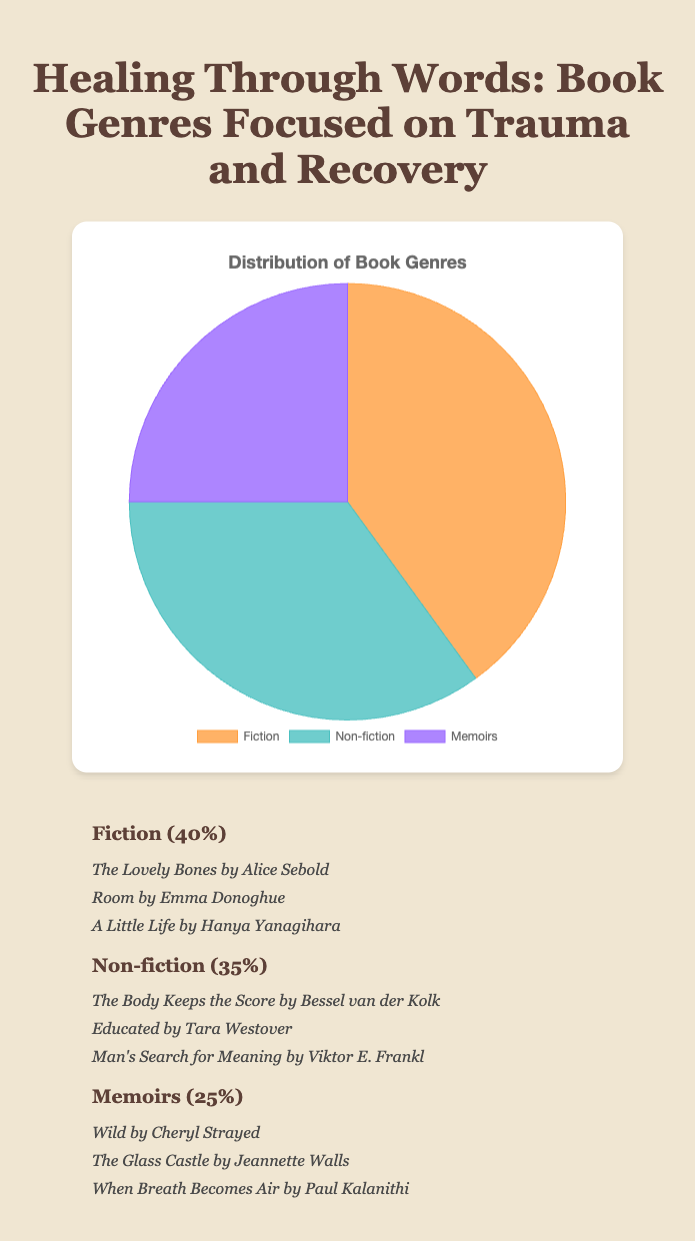What percentage of books focused on trauma and recovery belong to the Fiction genre? Looking at the pie chart, the Fiction portion accounts for 40% of the books focused on trauma and recovery.
Answer: 40% Which genre has the lowest percentage of books focused on trauma and recovery? By analyzing the pie chart, we can see that Memoirs have the smallest section, representing 25% of the books.
Answer: Memoirs How much greater is the percentage of Fiction books compared to Memoirs? Fiction accounts for 40%, while Memoirs account for 25%. The difference in percentage is 40% - 25% = 15%.
Answer: 15% What is the combined percentage of Non-fiction and Memoirs books focused on trauma and recovery? The Non-fiction portion is 35% and Memoirs is 25%. Adding these together gives 35% + 25% = 60%.
Answer: 60% Which genre has the second highest representation and what is its percentage? Referring to the pie chart, Non-fiction is the second largest section after Fiction, representing 35% of the books.
Answer: Non-fiction, 35% If you randomly pick a book from this collection, is it more likely to be a Memoir or Non-fiction? Non-fiction accounts for 35%, and Memoirs account for 25%. Since 35% is greater than 25%, it is more likely to pick a Non-fiction book.
Answer: Non-fiction How does the percentage of Fiction books compare visually to the percentage of Non-fiction books? Visually, the section for Fiction is larger than the section for Non-fiction, indicating that the Fiction percentage is greater.
Answer: Fiction is greater What's the total percentage of books in genres other than Memoirs? Non-Memoirs genres include Fiction and Non-fiction. Their combined percentage is 40% (Fiction) + 35% (Non-fiction) = 75%.
Answer: 75% What is the average percentage of books across the three genres? Adding the percentages of all three genres—40% (Fiction), 35% (Non-fiction), and 25% (Memoirs)—gives a total of 100%. Dividing by the three genres, we get 100% / 3 = 33.33%.
Answer: 33.33% Which genre is represented by the green section, and what books are examples of this genre? The green section represents Non-fiction, and examples include "The Body Keeps the Score," "Educated," and "Man's Search for Meaning."
Answer: Non-fiction, examples: "The Body Keeps the Score," "Educated," "Man's Search for Meaning." 